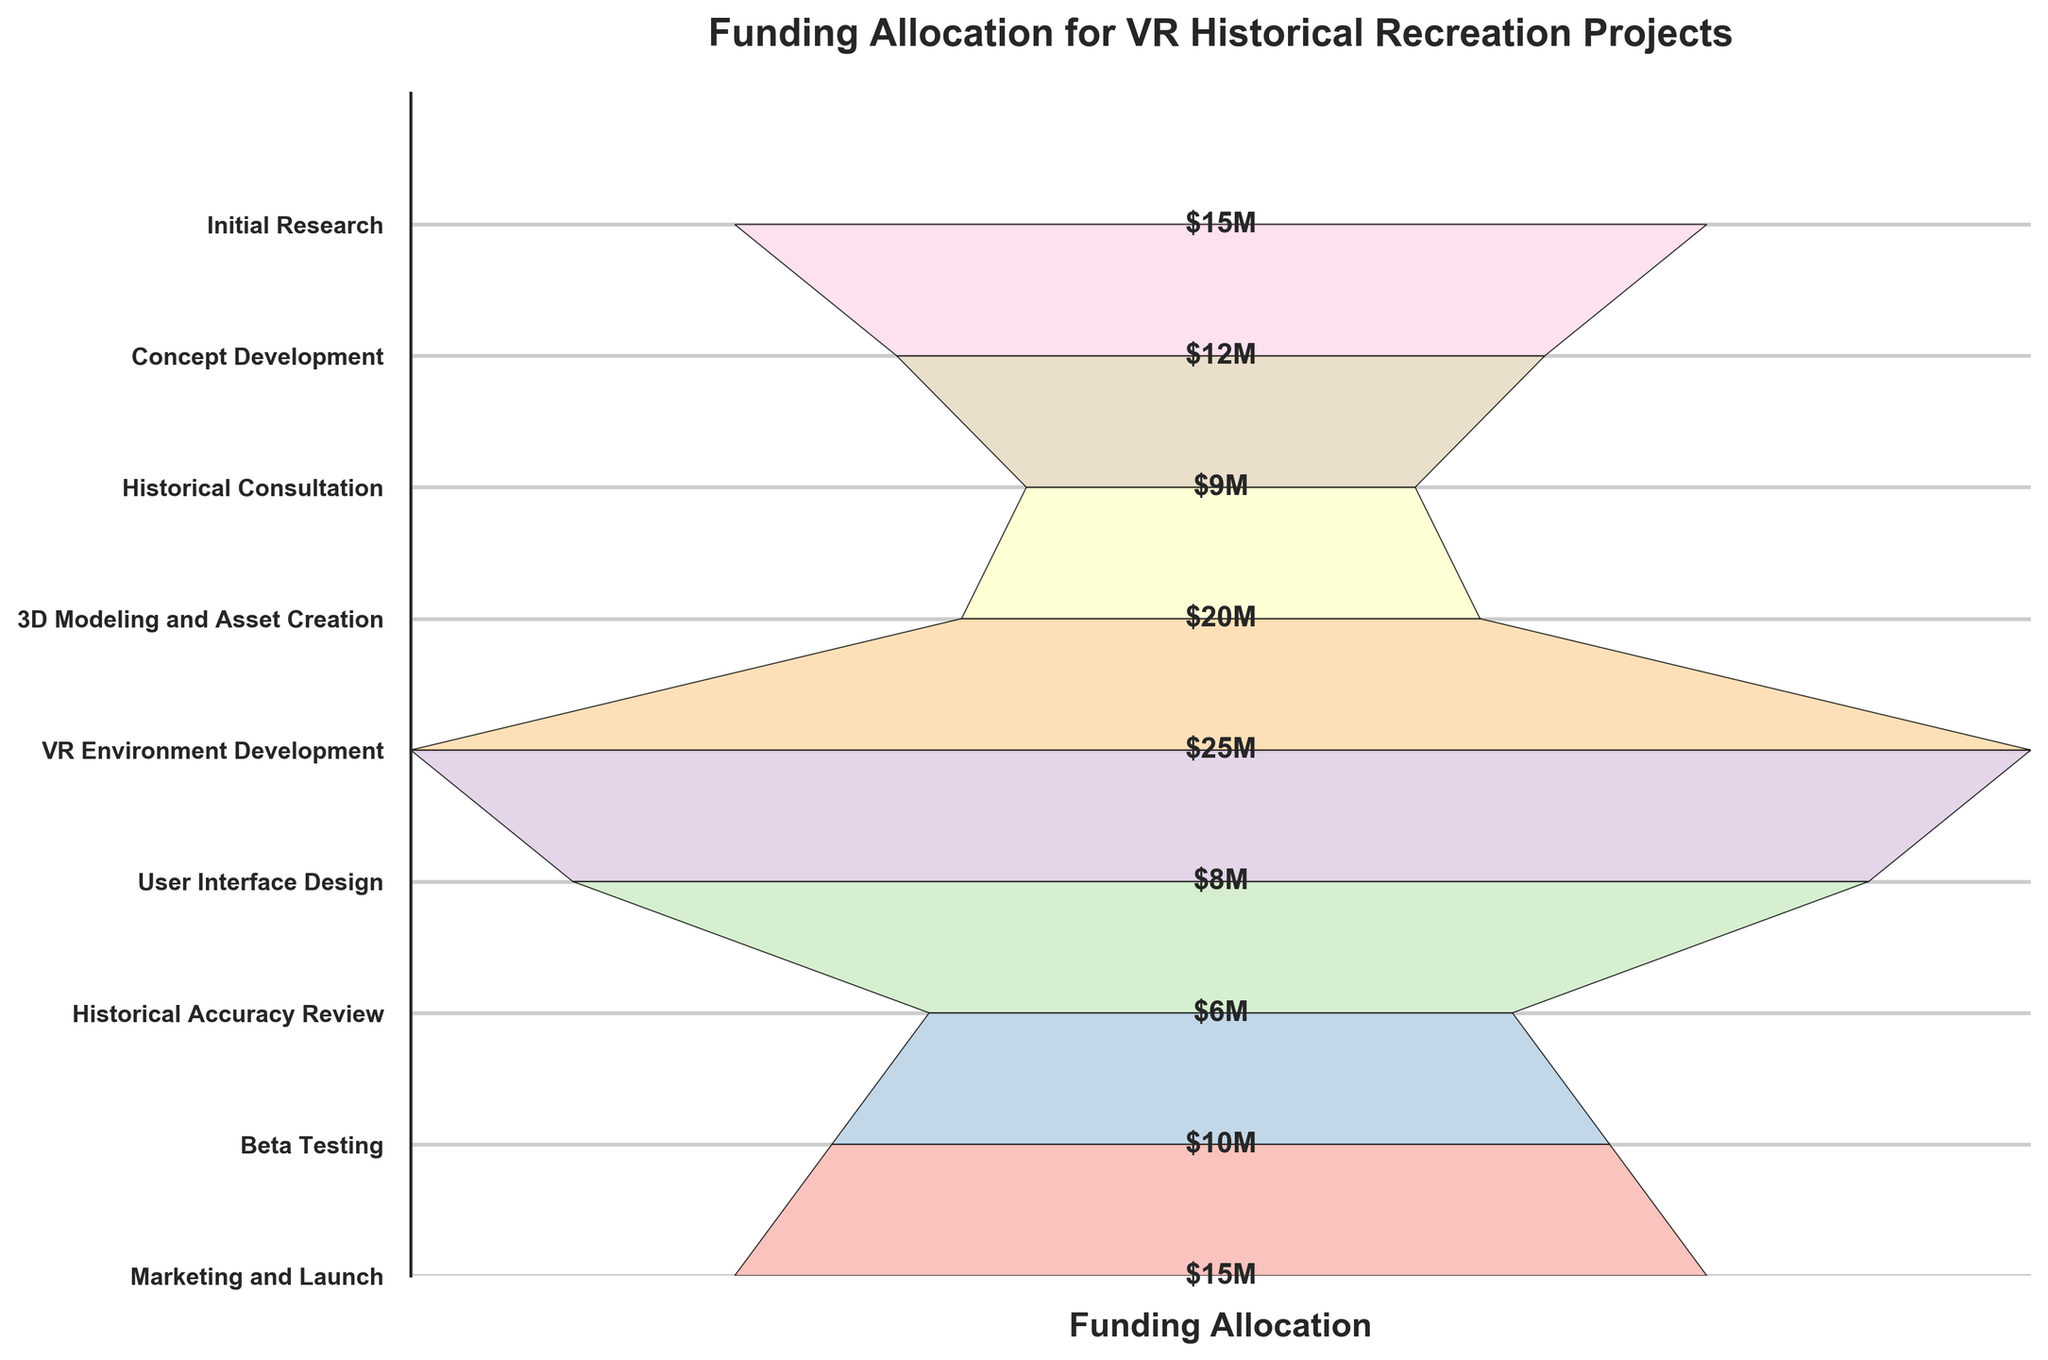What is the title of the funnel chart? The title of the chart is located at the top and is meant to provide a summary of the data being visualized. The title "Funding Allocation for VR Historical Recreation Projects" indicates that the chart represents how funding is distributed across different stages of a VR project.
Answer: Funding Allocation for VR Historical Recreation Projects Which development stage has the highest funding allocation? By observing the chart, you can see the stage with the widest section. The "VR Environment Development" stage has the largest allocation, showcased by the widest segment in the chart.
Answer: VR Environment Development How much funding is allocated to Beta Testing? The labels on the right side of the funnel chart correspond to each stage, and the funding allocation is written within the segment. The segment labeled "Beta Testing" shows an allocation of $10 million.
Answer: $10 million Which two stages have equal funding allocations? By comparing the segments visually, you can see that "Initial Research" and "Marketing and Launch" have segments of equal width, each marked with $15 million.
Answer: Initial Research and Marketing and Launch What is the total funding allocated for Historical Consultation and Historical Accuracy Review? Add the funding amounts for both stages: Historical Consultation ($9 million) and Historical Accuracy Review ($6 million). Summing them gives $9M + $6M = $15M.
Answer: $15 million How does the funding for Concept Development compare to User Interface Design? Locate both stages in the chart. "Concept Development" has $12 million, and "User Interface Design" has $8 million. Concept Development has greater funding by $4 million.
Answer: Concept Development has $4 million more What stage is immediately before VR Environment Development in terms of funding allocation? The chart is ordered so that the stages proceed from top to bottom. The stage immediately before ("above") VR Environment Development is "3D Modeling and Asset Creation."
Answer: 3D Modeling and Asset Creation By how much does the funding for the VR Environment Development stage exceed the funding for Historical Accuracy Review? Subtract the funding for Historical Accuracy Review ($6M) from VR Environment Development ($25M): $25M - $6M = $19M.
Answer: $19 million Which stage has the lowest funding allocation and what is it? By identifying the narrowest segment and its label, you can see that the "Historical Accuracy Review" stage has the lowest allocation of $6 million.
Answer: Historical Accuracy Review, $6 million 